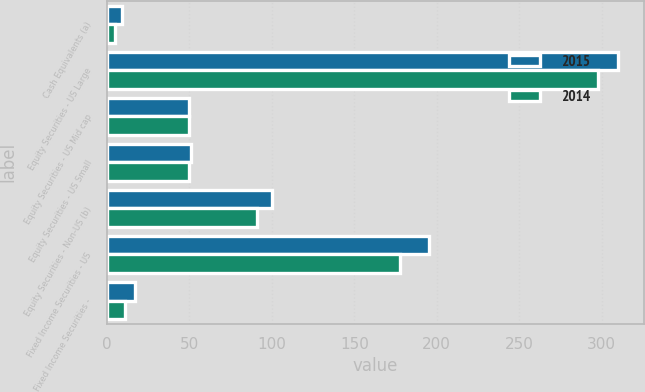<chart> <loc_0><loc_0><loc_500><loc_500><stacked_bar_chart><ecel><fcel>Cash Equivalents (a)<fcel>Equity Securities - US Large<fcel>Equity Securities - US Mid cap<fcel>Equity Securities - US Small<fcel>Equity Securities - Non-US (b)<fcel>Fixed Income Securities - US<fcel>Fixed Income Securities -<nl><fcel>2015<fcel>9<fcel>310<fcel>50<fcel>51<fcel>100<fcel>195<fcel>17<nl><fcel>2014<fcel>5<fcel>298<fcel>50<fcel>50<fcel>91<fcel>178<fcel>11<nl></chart> 